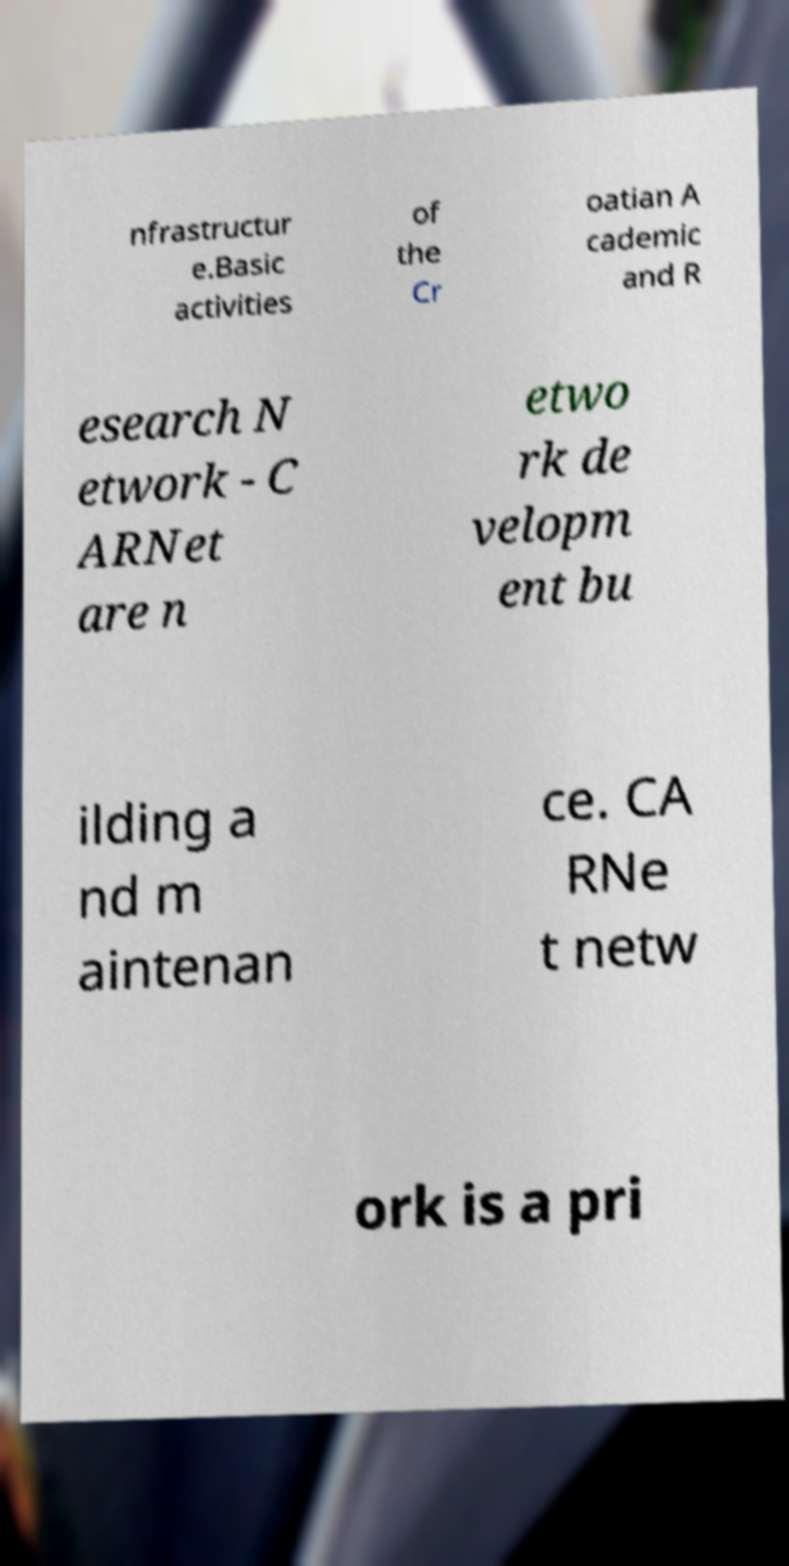Could you assist in decoding the text presented in this image and type it out clearly? nfrastructur e.Basic activities of the Cr oatian A cademic and R esearch N etwork - C ARNet are n etwo rk de velopm ent bu ilding a nd m aintenan ce. CA RNe t netw ork is a pri 